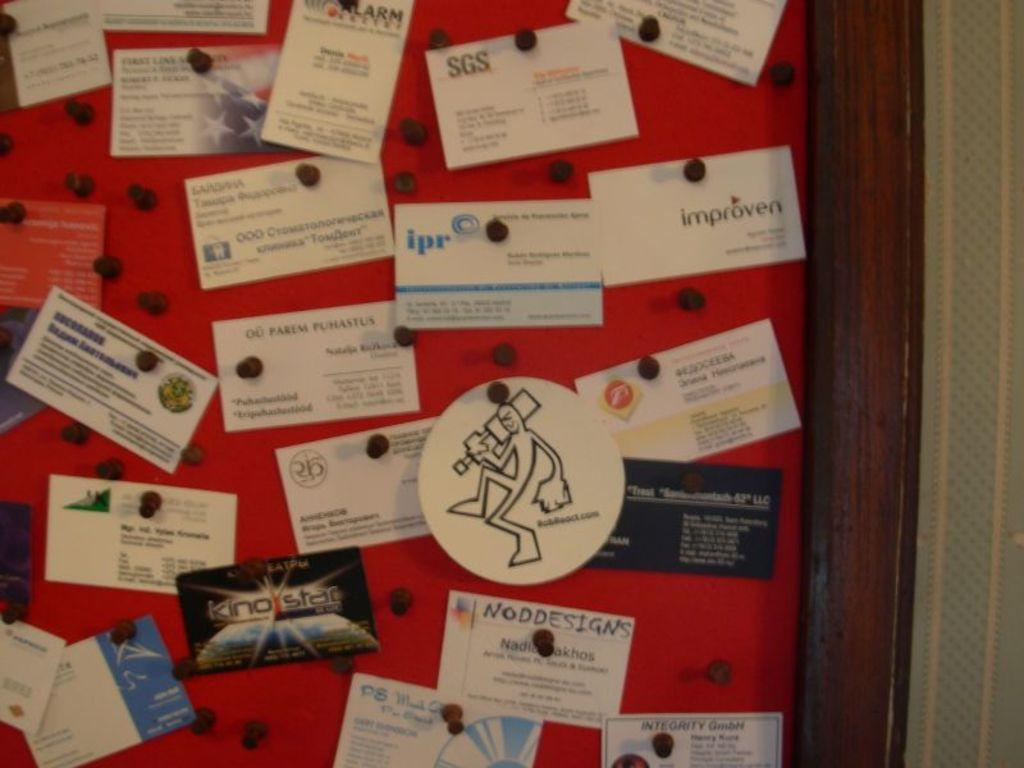Provide a one-sentence caption for the provided image. a note card with the letters ipr on it. 